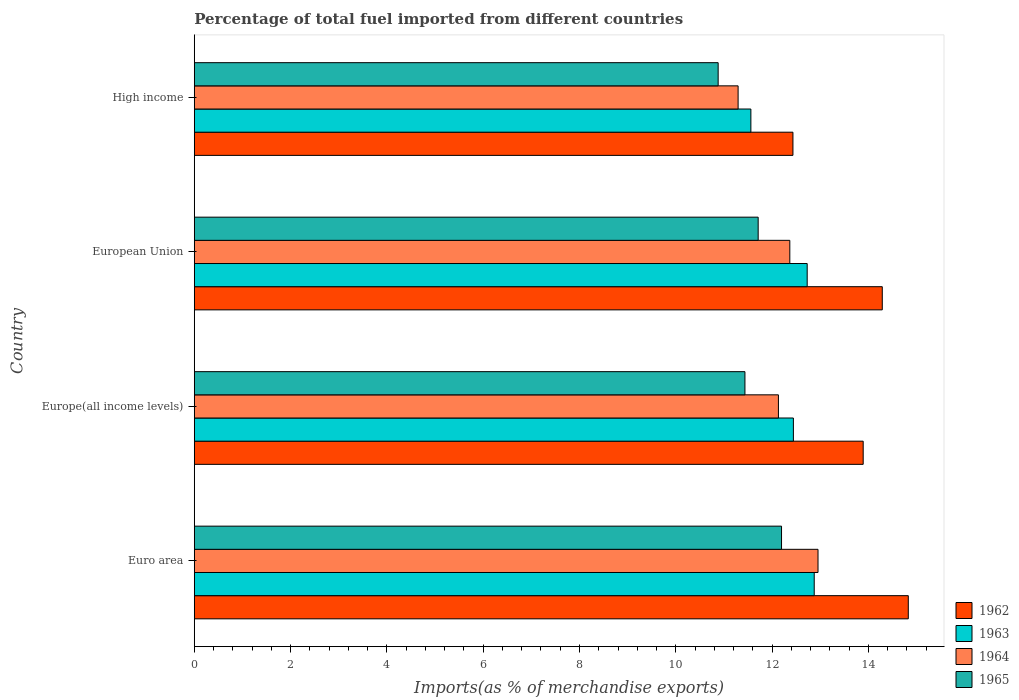How many different coloured bars are there?
Your answer should be very brief. 4. How many groups of bars are there?
Provide a succinct answer. 4. How many bars are there on the 1st tick from the bottom?
Your answer should be very brief. 4. What is the label of the 4th group of bars from the top?
Provide a succinct answer. Euro area. What is the percentage of imports to different countries in 1962 in Euro area?
Make the answer very short. 14.83. Across all countries, what is the maximum percentage of imports to different countries in 1964?
Provide a short and direct response. 12.95. Across all countries, what is the minimum percentage of imports to different countries in 1964?
Offer a terse response. 11.29. What is the total percentage of imports to different countries in 1965 in the graph?
Provide a short and direct response. 46.22. What is the difference between the percentage of imports to different countries in 1963 in Euro area and that in Europe(all income levels)?
Give a very brief answer. 0.43. What is the difference between the percentage of imports to different countries in 1965 in Euro area and the percentage of imports to different countries in 1962 in Europe(all income levels)?
Provide a short and direct response. -1.7. What is the average percentage of imports to different countries in 1965 per country?
Ensure brevity in your answer.  11.56. What is the difference between the percentage of imports to different countries in 1964 and percentage of imports to different countries in 1962 in Europe(all income levels)?
Your answer should be compact. -1.76. What is the ratio of the percentage of imports to different countries in 1965 in European Union to that in High income?
Offer a terse response. 1.08. Is the difference between the percentage of imports to different countries in 1964 in Euro area and European Union greater than the difference between the percentage of imports to different countries in 1962 in Euro area and European Union?
Provide a succinct answer. Yes. What is the difference between the highest and the second highest percentage of imports to different countries in 1965?
Ensure brevity in your answer.  0.49. What is the difference between the highest and the lowest percentage of imports to different countries in 1963?
Keep it short and to the point. 1.32. In how many countries, is the percentage of imports to different countries in 1963 greater than the average percentage of imports to different countries in 1963 taken over all countries?
Provide a short and direct response. 3. Is the sum of the percentage of imports to different countries in 1965 in Euro area and European Union greater than the maximum percentage of imports to different countries in 1962 across all countries?
Your response must be concise. Yes. What does the 1st bar from the top in Euro area represents?
Your answer should be very brief. 1965. Is it the case that in every country, the sum of the percentage of imports to different countries in 1962 and percentage of imports to different countries in 1965 is greater than the percentage of imports to different countries in 1963?
Make the answer very short. Yes. Where does the legend appear in the graph?
Give a very brief answer. Bottom right. How many legend labels are there?
Give a very brief answer. 4. How are the legend labels stacked?
Make the answer very short. Vertical. What is the title of the graph?
Your answer should be very brief. Percentage of total fuel imported from different countries. What is the label or title of the X-axis?
Provide a short and direct response. Imports(as % of merchandise exports). What is the label or title of the Y-axis?
Offer a terse response. Country. What is the Imports(as % of merchandise exports) of 1962 in Euro area?
Offer a terse response. 14.83. What is the Imports(as % of merchandise exports) in 1963 in Euro area?
Your answer should be compact. 12.88. What is the Imports(as % of merchandise exports) of 1964 in Euro area?
Make the answer very short. 12.95. What is the Imports(as % of merchandise exports) of 1965 in Euro area?
Provide a succinct answer. 12.2. What is the Imports(as % of merchandise exports) in 1962 in Europe(all income levels)?
Offer a very short reply. 13.89. What is the Imports(as % of merchandise exports) in 1963 in Europe(all income levels)?
Your answer should be very brief. 12.44. What is the Imports(as % of merchandise exports) of 1964 in Europe(all income levels)?
Your answer should be compact. 12.13. What is the Imports(as % of merchandise exports) in 1965 in Europe(all income levels)?
Provide a succinct answer. 11.44. What is the Imports(as % of merchandise exports) in 1962 in European Union?
Provide a short and direct response. 14.29. What is the Imports(as % of merchandise exports) of 1963 in European Union?
Provide a succinct answer. 12.73. What is the Imports(as % of merchandise exports) in 1964 in European Union?
Keep it short and to the point. 12.37. What is the Imports(as % of merchandise exports) of 1965 in European Union?
Provide a short and direct response. 11.71. What is the Imports(as % of merchandise exports) in 1962 in High income?
Give a very brief answer. 12.43. What is the Imports(as % of merchandise exports) of 1963 in High income?
Your answer should be very brief. 11.56. What is the Imports(as % of merchandise exports) of 1964 in High income?
Keep it short and to the point. 11.29. What is the Imports(as % of merchandise exports) of 1965 in High income?
Your answer should be compact. 10.88. Across all countries, what is the maximum Imports(as % of merchandise exports) in 1962?
Offer a very short reply. 14.83. Across all countries, what is the maximum Imports(as % of merchandise exports) in 1963?
Keep it short and to the point. 12.88. Across all countries, what is the maximum Imports(as % of merchandise exports) in 1964?
Your response must be concise. 12.95. Across all countries, what is the maximum Imports(as % of merchandise exports) in 1965?
Ensure brevity in your answer.  12.2. Across all countries, what is the minimum Imports(as % of merchandise exports) of 1962?
Offer a terse response. 12.43. Across all countries, what is the minimum Imports(as % of merchandise exports) of 1963?
Your response must be concise. 11.56. Across all countries, what is the minimum Imports(as % of merchandise exports) of 1964?
Ensure brevity in your answer.  11.29. Across all countries, what is the minimum Imports(as % of merchandise exports) in 1965?
Make the answer very short. 10.88. What is the total Imports(as % of merchandise exports) of 1962 in the graph?
Your answer should be compact. 55.44. What is the total Imports(as % of merchandise exports) in 1963 in the graph?
Make the answer very short. 49.61. What is the total Imports(as % of merchandise exports) in 1964 in the graph?
Provide a short and direct response. 48.75. What is the total Imports(as % of merchandise exports) of 1965 in the graph?
Offer a terse response. 46.22. What is the difference between the Imports(as % of merchandise exports) of 1962 in Euro area and that in Europe(all income levels)?
Offer a very short reply. 0.94. What is the difference between the Imports(as % of merchandise exports) in 1963 in Euro area and that in Europe(all income levels)?
Provide a succinct answer. 0.43. What is the difference between the Imports(as % of merchandise exports) of 1964 in Euro area and that in Europe(all income levels)?
Give a very brief answer. 0.82. What is the difference between the Imports(as % of merchandise exports) in 1965 in Euro area and that in Europe(all income levels)?
Give a very brief answer. 0.76. What is the difference between the Imports(as % of merchandise exports) of 1962 in Euro area and that in European Union?
Provide a short and direct response. 0.54. What is the difference between the Imports(as % of merchandise exports) of 1963 in Euro area and that in European Union?
Provide a succinct answer. 0.15. What is the difference between the Imports(as % of merchandise exports) of 1964 in Euro area and that in European Union?
Offer a very short reply. 0.59. What is the difference between the Imports(as % of merchandise exports) in 1965 in Euro area and that in European Union?
Your answer should be very brief. 0.49. What is the difference between the Imports(as % of merchandise exports) of 1962 in Euro area and that in High income?
Offer a terse response. 2.4. What is the difference between the Imports(as % of merchandise exports) of 1963 in Euro area and that in High income?
Your response must be concise. 1.32. What is the difference between the Imports(as % of merchandise exports) in 1964 in Euro area and that in High income?
Provide a short and direct response. 1.66. What is the difference between the Imports(as % of merchandise exports) of 1965 in Euro area and that in High income?
Your response must be concise. 1.32. What is the difference between the Imports(as % of merchandise exports) of 1962 in Europe(all income levels) and that in European Union?
Give a very brief answer. -0.4. What is the difference between the Imports(as % of merchandise exports) in 1963 in Europe(all income levels) and that in European Union?
Provide a short and direct response. -0.29. What is the difference between the Imports(as % of merchandise exports) in 1964 in Europe(all income levels) and that in European Union?
Provide a short and direct response. -0.24. What is the difference between the Imports(as % of merchandise exports) of 1965 in Europe(all income levels) and that in European Union?
Ensure brevity in your answer.  -0.27. What is the difference between the Imports(as % of merchandise exports) in 1962 in Europe(all income levels) and that in High income?
Keep it short and to the point. 1.46. What is the difference between the Imports(as % of merchandise exports) of 1963 in Europe(all income levels) and that in High income?
Your answer should be very brief. 0.88. What is the difference between the Imports(as % of merchandise exports) in 1964 in Europe(all income levels) and that in High income?
Your answer should be compact. 0.84. What is the difference between the Imports(as % of merchandise exports) of 1965 in Europe(all income levels) and that in High income?
Keep it short and to the point. 0.56. What is the difference between the Imports(as % of merchandise exports) of 1962 in European Union and that in High income?
Offer a very short reply. 1.86. What is the difference between the Imports(as % of merchandise exports) of 1963 in European Union and that in High income?
Ensure brevity in your answer.  1.17. What is the difference between the Imports(as % of merchandise exports) in 1964 in European Union and that in High income?
Provide a short and direct response. 1.07. What is the difference between the Imports(as % of merchandise exports) of 1965 in European Union and that in High income?
Your answer should be very brief. 0.83. What is the difference between the Imports(as % of merchandise exports) in 1962 in Euro area and the Imports(as % of merchandise exports) in 1963 in Europe(all income levels)?
Your response must be concise. 2.39. What is the difference between the Imports(as % of merchandise exports) in 1962 in Euro area and the Imports(as % of merchandise exports) in 1964 in Europe(all income levels)?
Provide a short and direct response. 2.7. What is the difference between the Imports(as % of merchandise exports) in 1962 in Euro area and the Imports(as % of merchandise exports) in 1965 in Europe(all income levels)?
Offer a very short reply. 3.39. What is the difference between the Imports(as % of merchandise exports) in 1963 in Euro area and the Imports(as % of merchandise exports) in 1964 in Europe(all income levels)?
Offer a terse response. 0.74. What is the difference between the Imports(as % of merchandise exports) of 1963 in Euro area and the Imports(as % of merchandise exports) of 1965 in Europe(all income levels)?
Give a very brief answer. 1.44. What is the difference between the Imports(as % of merchandise exports) in 1964 in Euro area and the Imports(as % of merchandise exports) in 1965 in Europe(all income levels)?
Give a very brief answer. 1.52. What is the difference between the Imports(as % of merchandise exports) in 1962 in Euro area and the Imports(as % of merchandise exports) in 1963 in European Union?
Give a very brief answer. 2.1. What is the difference between the Imports(as % of merchandise exports) in 1962 in Euro area and the Imports(as % of merchandise exports) in 1964 in European Union?
Your answer should be very brief. 2.46. What is the difference between the Imports(as % of merchandise exports) in 1962 in Euro area and the Imports(as % of merchandise exports) in 1965 in European Union?
Keep it short and to the point. 3.12. What is the difference between the Imports(as % of merchandise exports) in 1963 in Euro area and the Imports(as % of merchandise exports) in 1964 in European Union?
Provide a succinct answer. 0.51. What is the difference between the Imports(as % of merchandise exports) in 1963 in Euro area and the Imports(as % of merchandise exports) in 1965 in European Union?
Make the answer very short. 1.16. What is the difference between the Imports(as % of merchandise exports) of 1964 in Euro area and the Imports(as % of merchandise exports) of 1965 in European Union?
Provide a short and direct response. 1.24. What is the difference between the Imports(as % of merchandise exports) of 1962 in Euro area and the Imports(as % of merchandise exports) of 1963 in High income?
Keep it short and to the point. 3.27. What is the difference between the Imports(as % of merchandise exports) in 1962 in Euro area and the Imports(as % of merchandise exports) in 1964 in High income?
Ensure brevity in your answer.  3.53. What is the difference between the Imports(as % of merchandise exports) of 1962 in Euro area and the Imports(as % of merchandise exports) of 1965 in High income?
Keep it short and to the point. 3.95. What is the difference between the Imports(as % of merchandise exports) of 1963 in Euro area and the Imports(as % of merchandise exports) of 1964 in High income?
Provide a succinct answer. 1.58. What is the difference between the Imports(as % of merchandise exports) of 1963 in Euro area and the Imports(as % of merchandise exports) of 1965 in High income?
Provide a succinct answer. 2. What is the difference between the Imports(as % of merchandise exports) in 1964 in Euro area and the Imports(as % of merchandise exports) in 1965 in High income?
Offer a very short reply. 2.07. What is the difference between the Imports(as % of merchandise exports) of 1962 in Europe(all income levels) and the Imports(as % of merchandise exports) of 1963 in European Union?
Provide a short and direct response. 1.16. What is the difference between the Imports(as % of merchandise exports) in 1962 in Europe(all income levels) and the Imports(as % of merchandise exports) in 1964 in European Union?
Offer a terse response. 1.52. What is the difference between the Imports(as % of merchandise exports) in 1962 in Europe(all income levels) and the Imports(as % of merchandise exports) in 1965 in European Union?
Give a very brief answer. 2.18. What is the difference between the Imports(as % of merchandise exports) in 1963 in Europe(all income levels) and the Imports(as % of merchandise exports) in 1964 in European Union?
Offer a terse response. 0.07. What is the difference between the Imports(as % of merchandise exports) in 1963 in Europe(all income levels) and the Imports(as % of merchandise exports) in 1965 in European Union?
Give a very brief answer. 0.73. What is the difference between the Imports(as % of merchandise exports) of 1964 in Europe(all income levels) and the Imports(as % of merchandise exports) of 1965 in European Union?
Ensure brevity in your answer.  0.42. What is the difference between the Imports(as % of merchandise exports) in 1962 in Europe(all income levels) and the Imports(as % of merchandise exports) in 1963 in High income?
Your answer should be very brief. 2.33. What is the difference between the Imports(as % of merchandise exports) of 1962 in Europe(all income levels) and the Imports(as % of merchandise exports) of 1964 in High income?
Provide a succinct answer. 2.6. What is the difference between the Imports(as % of merchandise exports) of 1962 in Europe(all income levels) and the Imports(as % of merchandise exports) of 1965 in High income?
Keep it short and to the point. 3.01. What is the difference between the Imports(as % of merchandise exports) in 1963 in Europe(all income levels) and the Imports(as % of merchandise exports) in 1964 in High income?
Ensure brevity in your answer.  1.15. What is the difference between the Imports(as % of merchandise exports) in 1963 in Europe(all income levels) and the Imports(as % of merchandise exports) in 1965 in High income?
Offer a very short reply. 1.56. What is the difference between the Imports(as % of merchandise exports) of 1964 in Europe(all income levels) and the Imports(as % of merchandise exports) of 1965 in High income?
Provide a succinct answer. 1.25. What is the difference between the Imports(as % of merchandise exports) in 1962 in European Union and the Imports(as % of merchandise exports) in 1963 in High income?
Your response must be concise. 2.73. What is the difference between the Imports(as % of merchandise exports) of 1962 in European Union and the Imports(as % of merchandise exports) of 1964 in High income?
Give a very brief answer. 2.99. What is the difference between the Imports(as % of merchandise exports) in 1962 in European Union and the Imports(as % of merchandise exports) in 1965 in High income?
Your answer should be compact. 3.41. What is the difference between the Imports(as % of merchandise exports) of 1963 in European Union and the Imports(as % of merchandise exports) of 1964 in High income?
Your response must be concise. 1.43. What is the difference between the Imports(as % of merchandise exports) in 1963 in European Union and the Imports(as % of merchandise exports) in 1965 in High income?
Offer a terse response. 1.85. What is the difference between the Imports(as % of merchandise exports) in 1964 in European Union and the Imports(as % of merchandise exports) in 1965 in High income?
Provide a short and direct response. 1.49. What is the average Imports(as % of merchandise exports) in 1962 per country?
Make the answer very short. 13.86. What is the average Imports(as % of merchandise exports) of 1963 per country?
Make the answer very short. 12.4. What is the average Imports(as % of merchandise exports) in 1964 per country?
Your answer should be very brief. 12.19. What is the average Imports(as % of merchandise exports) in 1965 per country?
Ensure brevity in your answer.  11.56. What is the difference between the Imports(as % of merchandise exports) in 1962 and Imports(as % of merchandise exports) in 1963 in Euro area?
Provide a short and direct response. 1.95. What is the difference between the Imports(as % of merchandise exports) of 1962 and Imports(as % of merchandise exports) of 1964 in Euro area?
Provide a short and direct response. 1.87. What is the difference between the Imports(as % of merchandise exports) of 1962 and Imports(as % of merchandise exports) of 1965 in Euro area?
Your answer should be compact. 2.63. What is the difference between the Imports(as % of merchandise exports) in 1963 and Imports(as % of merchandise exports) in 1964 in Euro area?
Offer a terse response. -0.08. What is the difference between the Imports(as % of merchandise exports) of 1963 and Imports(as % of merchandise exports) of 1965 in Euro area?
Offer a very short reply. 0.68. What is the difference between the Imports(as % of merchandise exports) of 1964 and Imports(as % of merchandise exports) of 1965 in Euro area?
Ensure brevity in your answer.  0.76. What is the difference between the Imports(as % of merchandise exports) of 1962 and Imports(as % of merchandise exports) of 1963 in Europe(all income levels)?
Provide a succinct answer. 1.45. What is the difference between the Imports(as % of merchandise exports) of 1962 and Imports(as % of merchandise exports) of 1964 in Europe(all income levels)?
Offer a terse response. 1.76. What is the difference between the Imports(as % of merchandise exports) in 1962 and Imports(as % of merchandise exports) in 1965 in Europe(all income levels)?
Offer a very short reply. 2.46. What is the difference between the Imports(as % of merchandise exports) of 1963 and Imports(as % of merchandise exports) of 1964 in Europe(all income levels)?
Keep it short and to the point. 0.31. What is the difference between the Imports(as % of merchandise exports) of 1963 and Imports(as % of merchandise exports) of 1965 in Europe(all income levels)?
Ensure brevity in your answer.  1.01. What is the difference between the Imports(as % of merchandise exports) in 1964 and Imports(as % of merchandise exports) in 1965 in Europe(all income levels)?
Make the answer very short. 0.7. What is the difference between the Imports(as % of merchandise exports) in 1962 and Imports(as % of merchandise exports) in 1963 in European Union?
Your response must be concise. 1.56. What is the difference between the Imports(as % of merchandise exports) of 1962 and Imports(as % of merchandise exports) of 1964 in European Union?
Make the answer very short. 1.92. What is the difference between the Imports(as % of merchandise exports) of 1962 and Imports(as % of merchandise exports) of 1965 in European Union?
Your response must be concise. 2.58. What is the difference between the Imports(as % of merchandise exports) of 1963 and Imports(as % of merchandise exports) of 1964 in European Union?
Offer a very short reply. 0.36. What is the difference between the Imports(as % of merchandise exports) in 1963 and Imports(as % of merchandise exports) in 1965 in European Union?
Provide a short and direct response. 1.02. What is the difference between the Imports(as % of merchandise exports) in 1964 and Imports(as % of merchandise exports) in 1965 in European Union?
Offer a very short reply. 0.66. What is the difference between the Imports(as % of merchandise exports) of 1962 and Imports(as % of merchandise exports) of 1963 in High income?
Your answer should be very brief. 0.87. What is the difference between the Imports(as % of merchandise exports) of 1962 and Imports(as % of merchandise exports) of 1964 in High income?
Keep it short and to the point. 1.14. What is the difference between the Imports(as % of merchandise exports) of 1962 and Imports(as % of merchandise exports) of 1965 in High income?
Provide a succinct answer. 1.55. What is the difference between the Imports(as % of merchandise exports) in 1963 and Imports(as % of merchandise exports) in 1964 in High income?
Offer a terse response. 0.27. What is the difference between the Imports(as % of merchandise exports) in 1963 and Imports(as % of merchandise exports) in 1965 in High income?
Provide a short and direct response. 0.68. What is the difference between the Imports(as % of merchandise exports) of 1964 and Imports(as % of merchandise exports) of 1965 in High income?
Provide a short and direct response. 0.41. What is the ratio of the Imports(as % of merchandise exports) in 1962 in Euro area to that in Europe(all income levels)?
Provide a succinct answer. 1.07. What is the ratio of the Imports(as % of merchandise exports) of 1963 in Euro area to that in Europe(all income levels)?
Give a very brief answer. 1.03. What is the ratio of the Imports(as % of merchandise exports) of 1964 in Euro area to that in Europe(all income levels)?
Provide a short and direct response. 1.07. What is the ratio of the Imports(as % of merchandise exports) in 1965 in Euro area to that in Europe(all income levels)?
Give a very brief answer. 1.07. What is the ratio of the Imports(as % of merchandise exports) in 1962 in Euro area to that in European Union?
Ensure brevity in your answer.  1.04. What is the ratio of the Imports(as % of merchandise exports) in 1963 in Euro area to that in European Union?
Offer a terse response. 1.01. What is the ratio of the Imports(as % of merchandise exports) in 1964 in Euro area to that in European Union?
Provide a succinct answer. 1.05. What is the ratio of the Imports(as % of merchandise exports) of 1965 in Euro area to that in European Union?
Make the answer very short. 1.04. What is the ratio of the Imports(as % of merchandise exports) of 1962 in Euro area to that in High income?
Your answer should be very brief. 1.19. What is the ratio of the Imports(as % of merchandise exports) of 1963 in Euro area to that in High income?
Provide a short and direct response. 1.11. What is the ratio of the Imports(as % of merchandise exports) in 1964 in Euro area to that in High income?
Offer a very short reply. 1.15. What is the ratio of the Imports(as % of merchandise exports) in 1965 in Euro area to that in High income?
Your response must be concise. 1.12. What is the ratio of the Imports(as % of merchandise exports) of 1962 in Europe(all income levels) to that in European Union?
Ensure brevity in your answer.  0.97. What is the ratio of the Imports(as % of merchandise exports) of 1963 in Europe(all income levels) to that in European Union?
Provide a short and direct response. 0.98. What is the ratio of the Imports(as % of merchandise exports) in 1964 in Europe(all income levels) to that in European Union?
Provide a succinct answer. 0.98. What is the ratio of the Imports(as % of merchandise exports) in 1965 in Europe(all income levels) to that in European Union?
Make the answer very short. 0.98. What is the ratio of the Imports(as % of merchandise exports) of 1962 in Europe(all income levels) to that in High income?
Provide a short and direct response. 1.12. What is the ratio of the Imports(as % of merchandise exports) in 1963 in Europe(all income levels) to that in High income?
Provide a succinct answer. 1.08. What is the ratio of the Imports(as % of merchandise exports) of 1964 in Europe(all income levels) to that in High income?
Give a very brief answer. 1.07. What is the ratio of the Imports(as % of merchandise exports) in 1965 in Europe(all income levels) to that in High income?
Make the answer very short. 1.05. What is the ratio of the Imports(as % of merchandise exports) of 1962 in European Union to that in High income?
Offer a very short reply. 1.15. What is the ratio of the Imports(as % of merchandise exports) of 1963 in European Union to that in High income?
Give a very brief answer. 1.1. What is the ratio of the Imports(as % of merchandise exports) in 1964 in European Union to that in High income?
Give a very brief answer. 1.1. What is the ratio of the Imports(as % of merchandise exports) of 1965 in European Union to that in High income?
Give a very brief answer. 1.08. What is the difference between the highest and the second highest Imports(as % of merchandise exports) in 1962?
Offer a very short reply. 0.54. What is the difference between the highest and the second highest Imports(as % of merchandise exports) of 1963?
Keep it short and to the point. 0.15. What is the difference between the highest and the second highest Imports(as % of merchandise exports) of 1964?
Ensure brevity in your answer.  0.59. What is the difference between the highest and the second highest Imports(as % of merchandise exports) in 1965?
Make the answer very short. 0.49. What is the difference between the highest and the lowest Imports(as % of merchandise exports) in 1962?
Ensure brevity in your answer.  2.4. What is the difference between the highest and the lowest Imports(as % of merchandise exports) of 1963?
Offer a terse response. 1.32. What is the difference between the highest and the lowest Imports(as % of merchandise exports) of 1964?
Your answer should be very brief. 1.66. What is the difference between the highest and the lowest Imports(as % of merchandise exports) of 1965?
Ensure brevity in your answer.  1.32. 